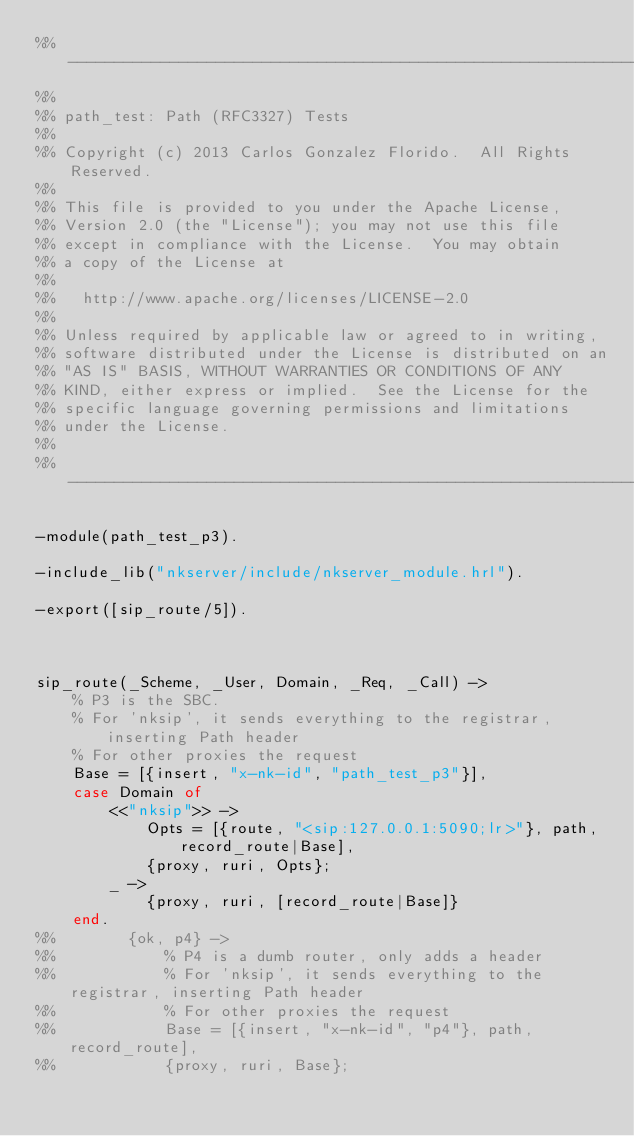Convert code to text. <code><loc_0><loc_0><loc_500><loc_500><_Erlang_>%% -------------------------------------------------------------------
%%
%% path_test: Path (RFC3327) Tests
%%
%% Copyright (c) 2013 Carlos Gonzalez Florido.  All Rights Reserved.
%%
%% This file is provided to you under the Apache License,
%% Version 2.0 (the "License"); you may not use this file
%% except in compliance with the License.  You may obtain
%% a copy of the License at
%%
%%   http://www.apache.org/licenses/LICENSE-2.0
%%
%% Unless required by applicable law or agreed to in writing,
%% software distributed under the License is distributed on an
%% "AS IS" BASIS, WITHOUT WARRANTIES OR CONDITIONS OF ANY
%% KIND, either express or implied.  See the License for the
%% specific language governing permissions and limitations
%% under the License.
%%
%% -------------------------------------------------------------------

-module(path_test_p3).

-include_lib("nkserver/include/nkserver_module.hrl").

-export([sip_route/5]).



sip_route(_Scheme, _User, Domain, _Req, _Call) ->
    % P3 is the SBC.
    % For 'nksip', it sends everything to the registrar, inserting Path header
    % For other proxies the request
    Base = [{insert, "x-nk-id", "path_test_p3"}],
    case Domain of
        <<"nksip">> ->
            Opts = [{route, "<sip:127.0.0.1:5090;lr>"}, path, record_route|Base],
            {proxy, ruri, Opts};
        _ ->
            {proxy, ruri, [record_route|Base]}
    end.
%%        {ok, p4} ->
%%            % P4 is a dumb router, only adds a header
%%            % For 'nksip', it sends everything to the registrar, inserting Path header
%%            % For other proxies the request
%%            Base = [{insert, "x-nk-id", "p4"}, path, record_route],
%%            {proxy, ruri, Base};
</code> 